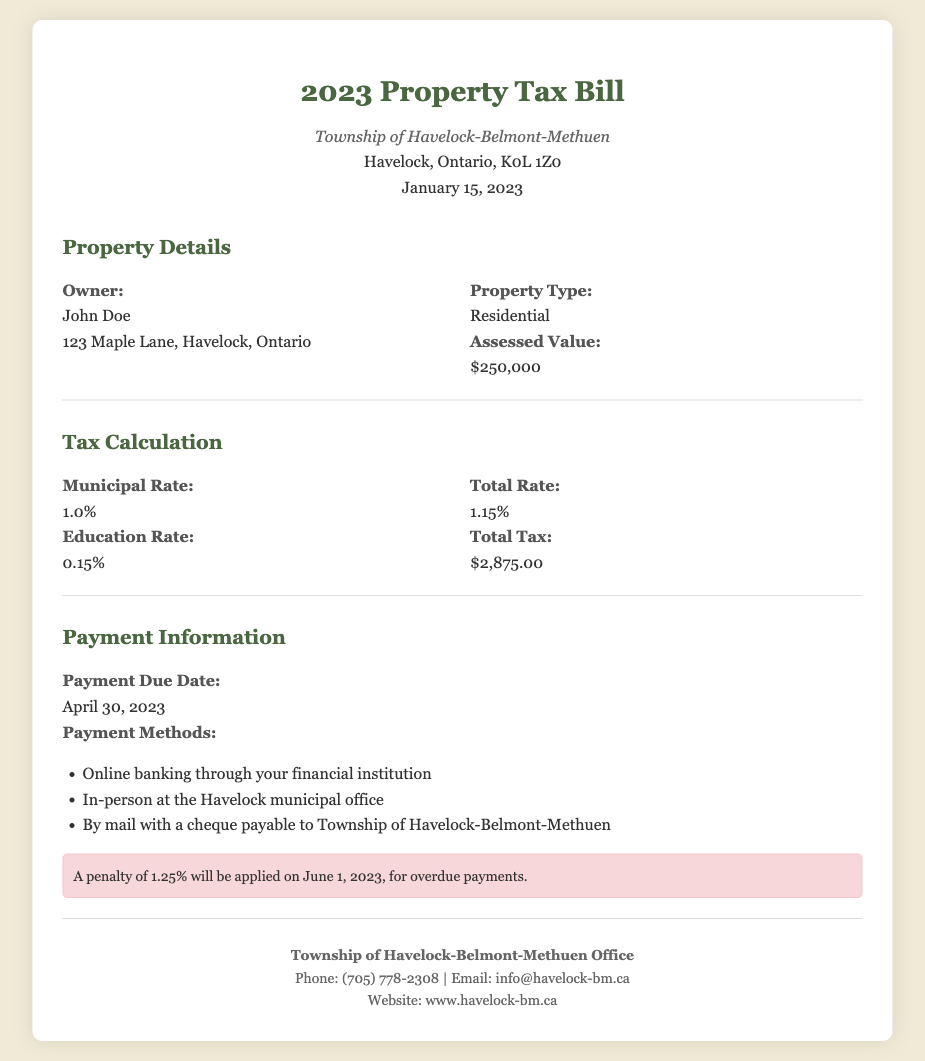What is the assessed value of the property? The assessed value is stated in the property details section of the document.
Answer: $250,000 What is the municipal rate? The municipal rate is part of the tax calculation section and reflects the percentage for municipal taxes.
Answer: 1.0% When is the payment due date? The payment due date is specified in the payment information section of the document.
Answer: April 30, 2023 What is the total tax amount? The total tax amount is derived from the tax calculation section and represents the total amount due.
Answer: $2,875.00 What penalty will be applied for overdue payments? The penalty details are mentioned in the payment information section regarding overdue payments.
Answer: 1.25% What are the payment methods available? The payment methods are listed in the payment information section, indicating how one can pay the tax bill.
Answer: Online banking, in-person, by mail What is the education rate? The education rate is part of the tax calculation and reflects the percentage allocated for educational taxes.
Answer: 0.15% Who is the owner of the property? The owner's name is provided in the property details section of the document.
Answer: John Doe What is the total rate? The total rate is calculated from both municipal and education rates in the tax calculation section.
Answer: 1.15% 